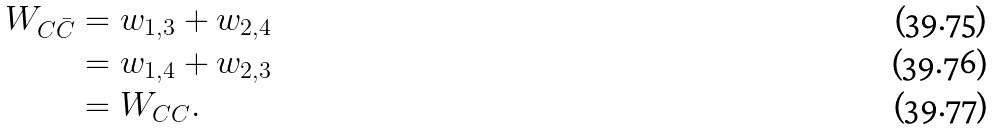Convert formula to latex. <formula><loc_0><loc_0><loc_500><loc_500>W _ { C \bar { C } } & = w _ { 1 , 3 } + w _ { 2 , 4 } \\ & = w _ { 1 , 4 } + w _ { 2 , 3 } \\ & = W _ { C C } .</formula> 